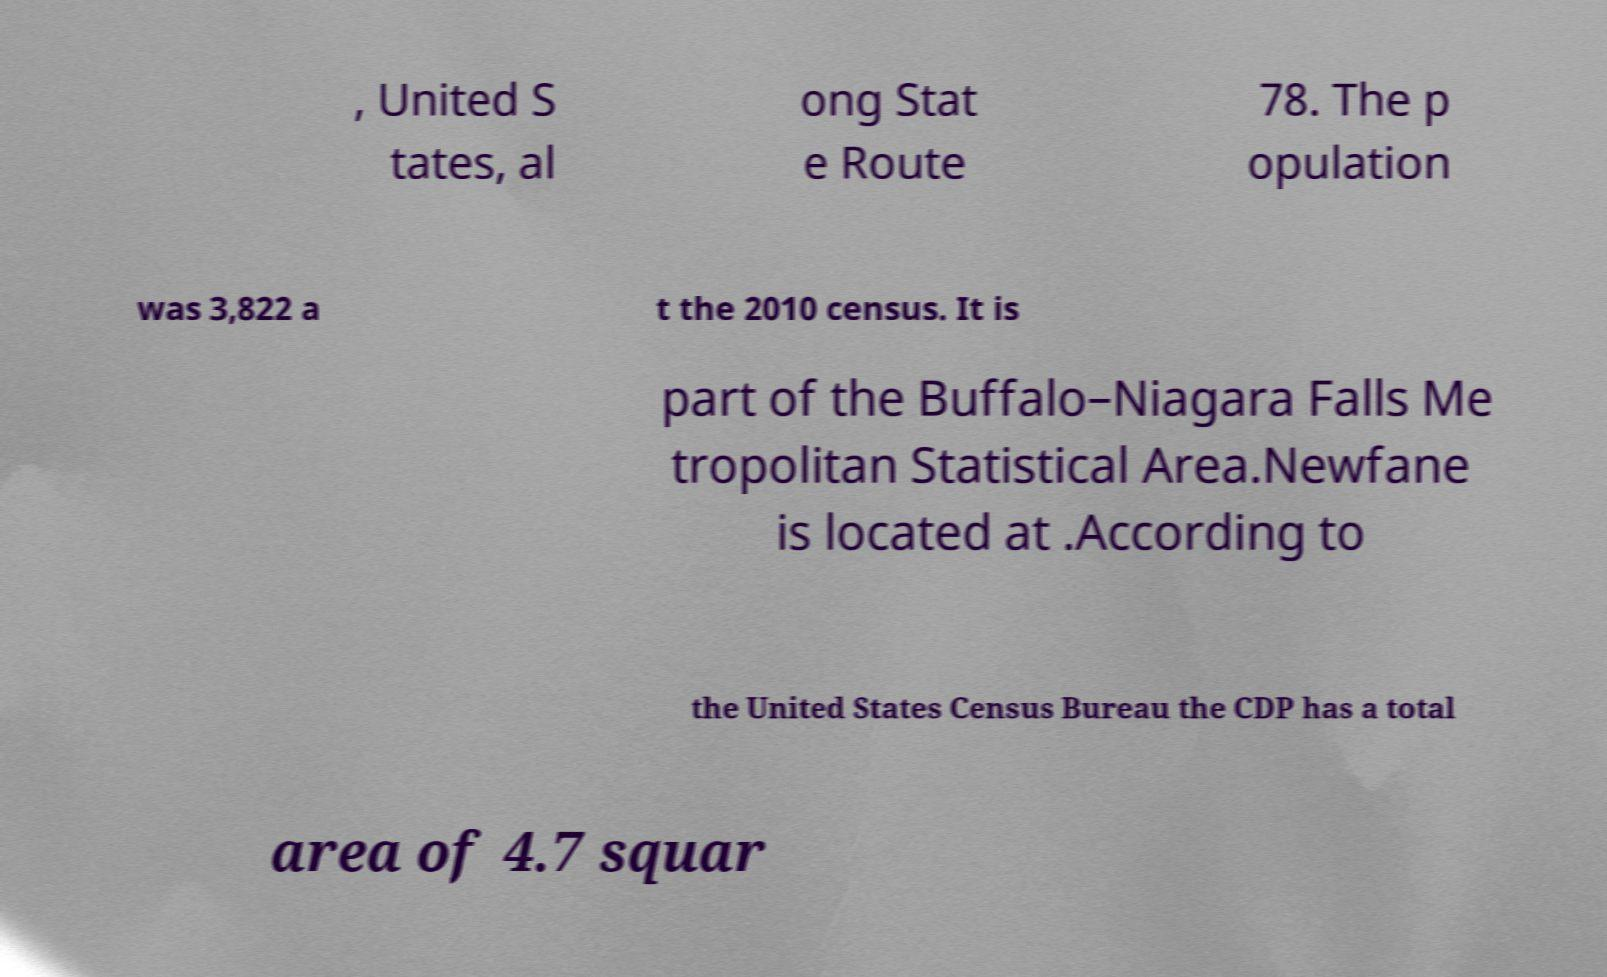Please read and relay the text visible in this image. What does it say? , United S tates, al ong Stat e Route 78. The p opulation was 3,822 a t the 2010 census. It is part of the Buffalo–Niagara Falls Me tropolitan Statistical Area.Newfane is located at .According to the United States Census Bureau the CDP has a total area of 4.7 squar 